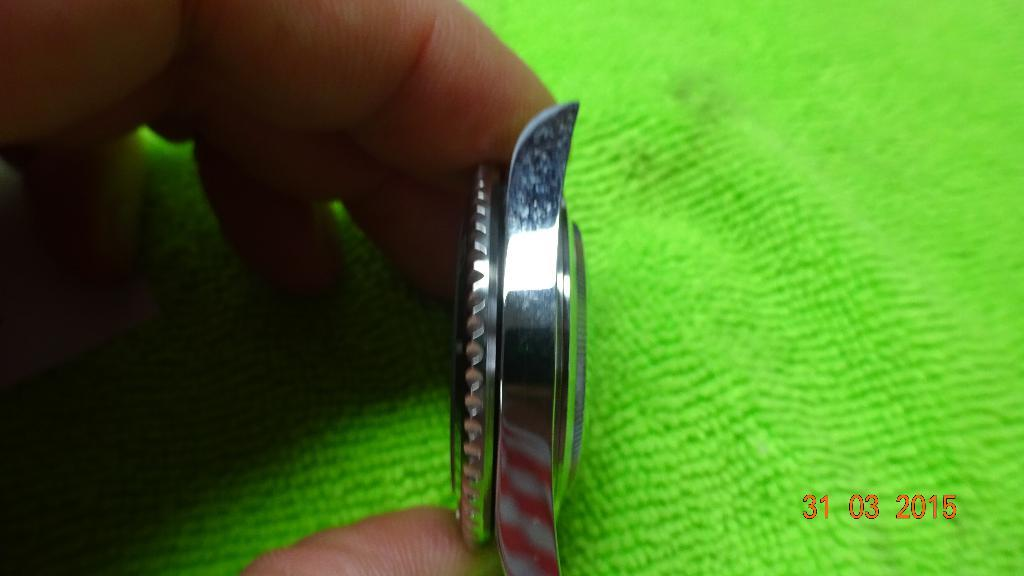<image>
Relay a brief, clear account of the picture shown. A watch is displayed from the side on March 3 2015. 